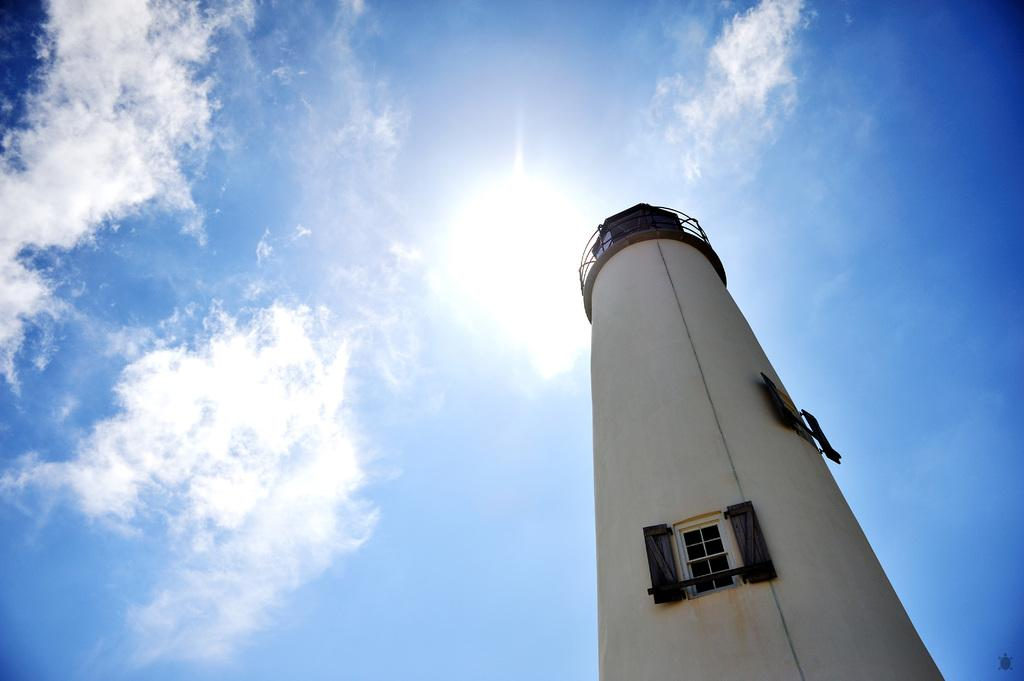What is the main structure in the image? There is a tower in the image. What is the color of the tower? The tower is white in color. Does the tower have any specific features? Yes, the tower has windows. What can be seen in the background of the image? There are clouds and the sun visible in the background of the image. What is the color of the sky in the image? The sky is blue in color. Can you hear the iron whistling in the image? There is no iron or whistling sound present in the image. 